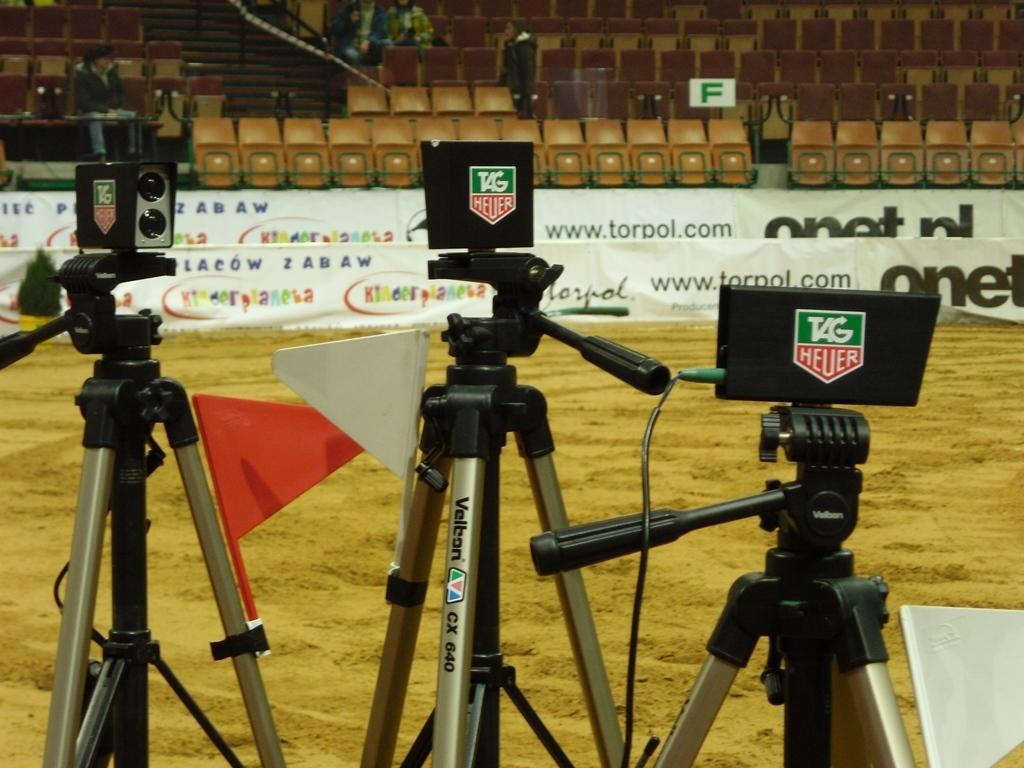Can you describe this image briefly? In the center of the image we can see stands, cameras, flags and one white color object. In the background, we can see a few attached chairs, banners, few people and some objects. 